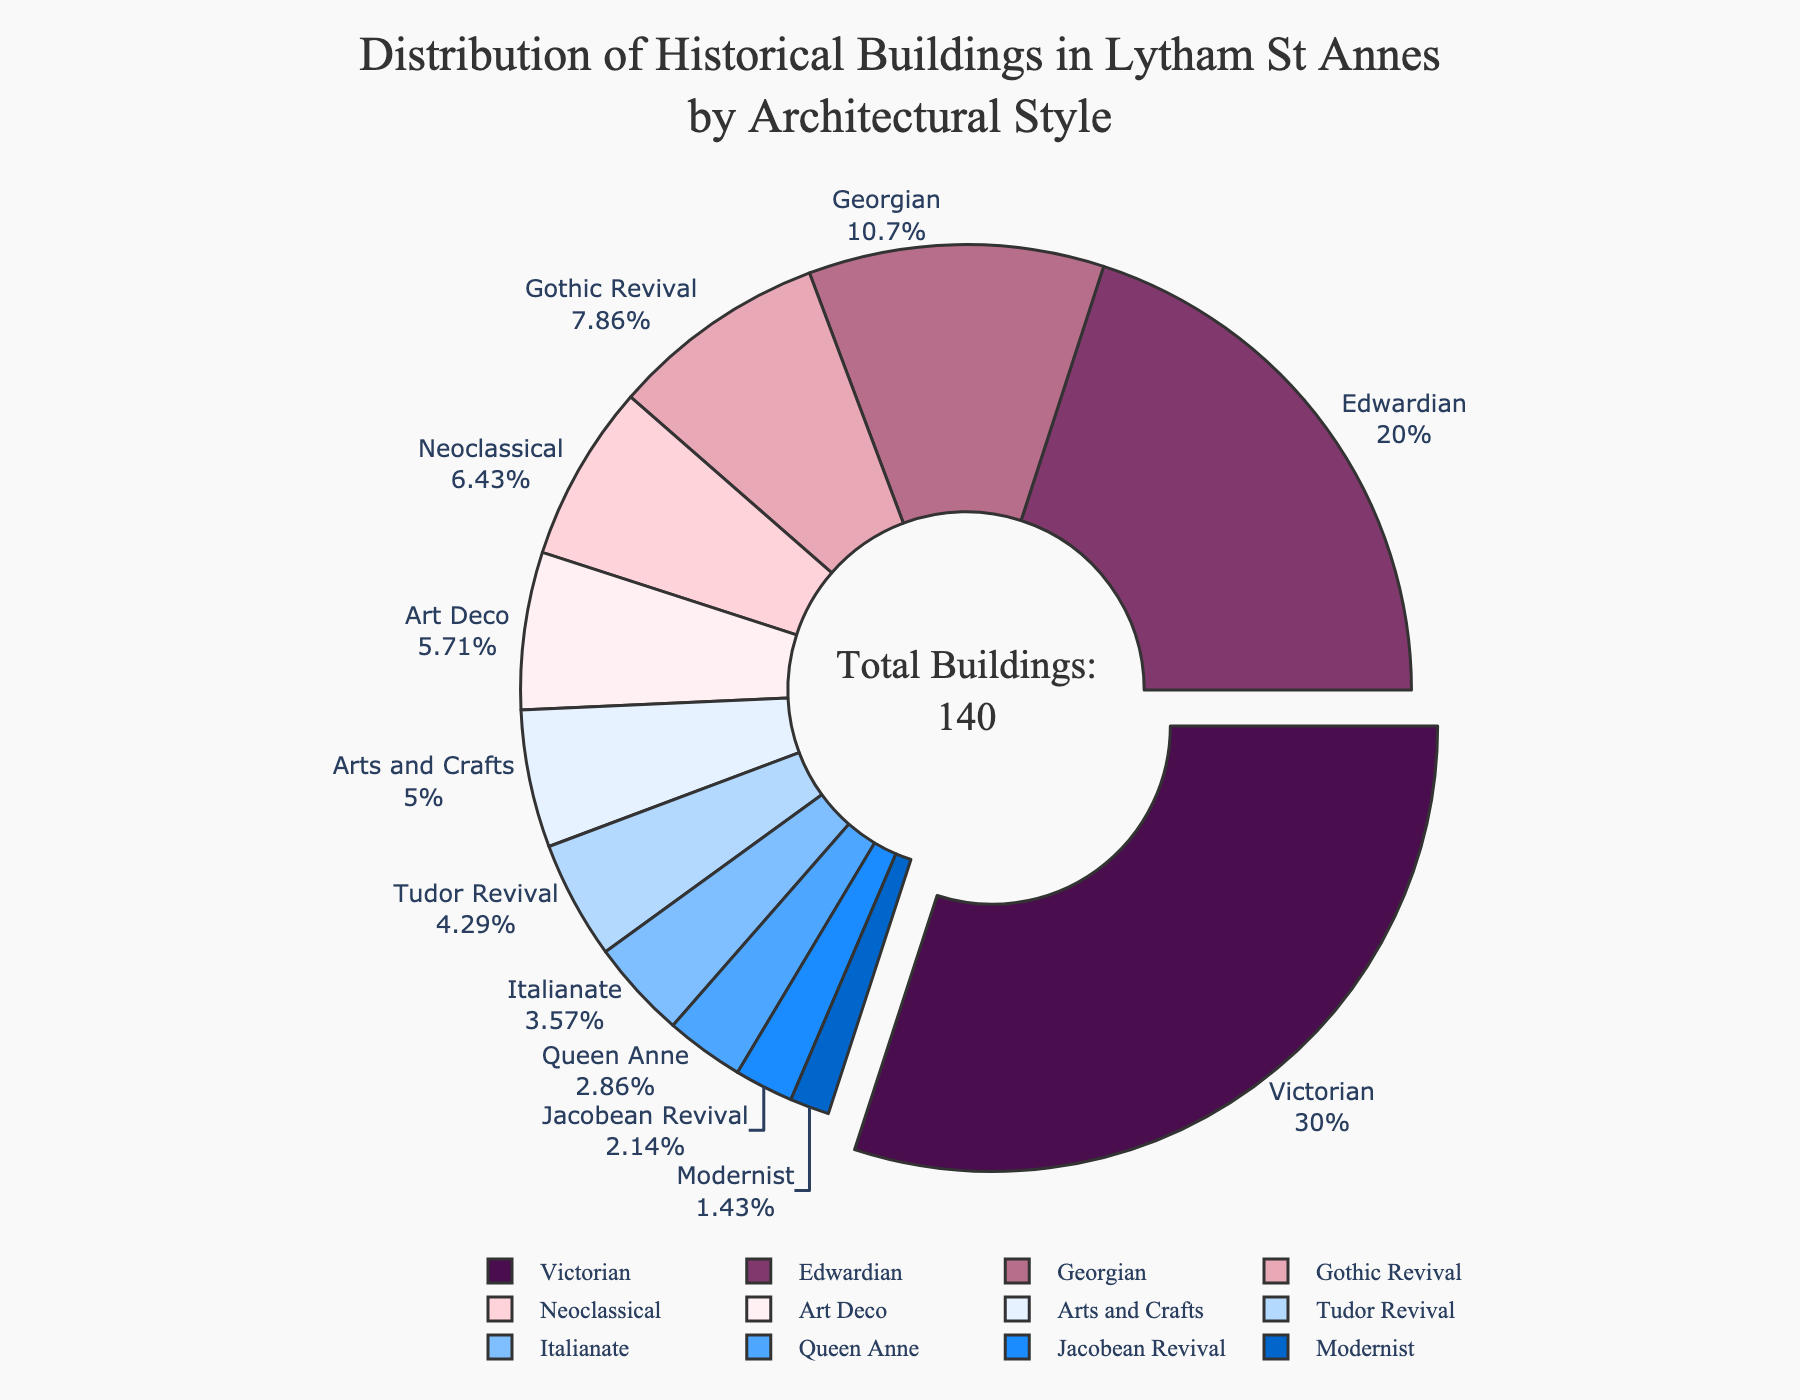What's the most common architectural style among historical buildings in Lytham St Annes? The largest segment of the pie chart represents the Victorian architectural style, indicating it has the highest number of buildings.
Answer: Victorian How many more Victorian buildings are there than Edwardian buildings? There are 42 Victorian buildings and 28 Edwardian buildings. Subtracting the two, 42 - 28 = 14.
Answer: 14 What percentage of the buildings are Edwardian? The pie chart shows values in percentages. The Edwardian segment shows 20%.
Answer: 20% Are there more Gothic Revival or Neoclassical buildings? Comparing the slices for Gothic Revival and Neoclassical, Gothic Revival has a larger slice of the pie chart.
Answer: Gothic Revival What's the combined percentage of Georgian and Art Deco buildings? The Georgian slice shows 10.7% and the Art Deco slice shows 5.7%. Adding them, 10.7% + 5.7% = 16.4%.
Answer: 16.4% Which architectural style has the smallest number of buildings, and how many are there? The smallest segment corresponds to the Modernist style, which has 2 buildings.
Answer: Modernist, 2 What's the difference in the number of buildings between Tudor Revival and Arts and Crafts? Tudor Revival has 6 buildings, and Arts and Crafts has 7. The difference is 7 - 6 = 1.
Answer: 1 What is the color of the Art Deco segment in the pie chart? The Art Deco segment is represented by a pastel pink color.
Answer: Pastel pink How many architectural styles have more than 20 buildings? The pie chart shows segments with more than 20 buildings are Victorian and Edwardian.
Answer: 2 What is the total number of historical buildings shown in the pie chart? The total number of buildings is explicitly mentioned in the annotation in the center of the pie chart, which is 140.
Answer: 140 